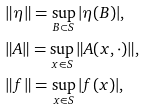Convert formula to latex. <formula><loc_0><loc_0><loc_500><loc_500>& \| \eta \| = \sup _ { B \subset S } | \eta ( B ) | , \\ & \| A \| = \sup _ { x \in S } \| A ( x , \cdot ) \| , \\ & \| f \| = \sup _ { x \in S } | f ( x ) | ,</formula> 